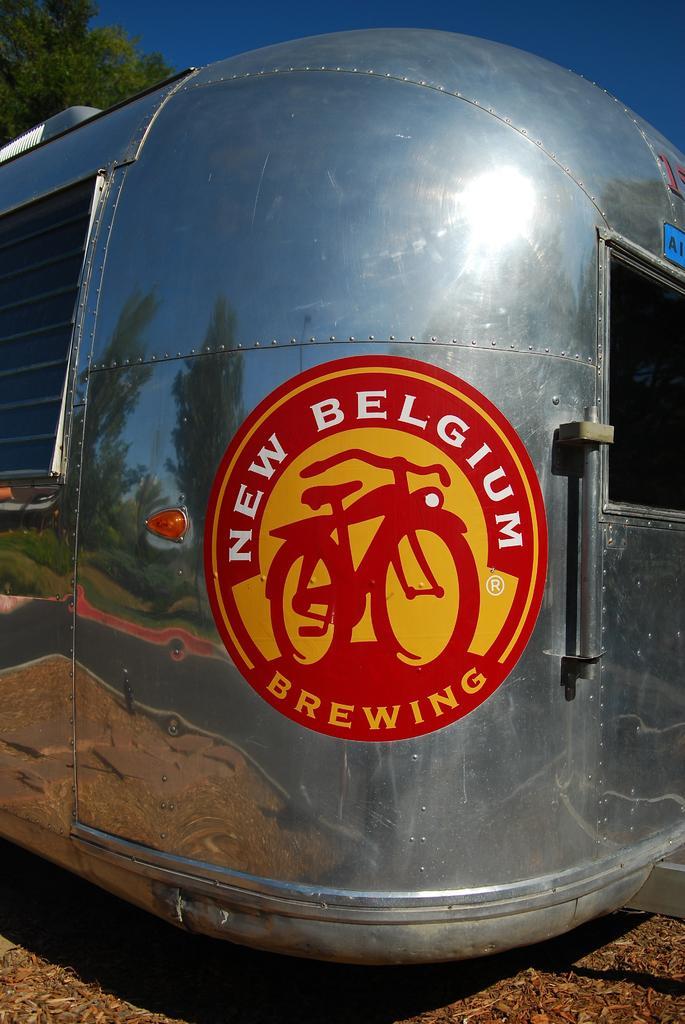Could you give a brief overview of what you see in this image? In this image in the front there is an object which is silver in colour and on the object there is some text written on it. In the background there is a tree. 